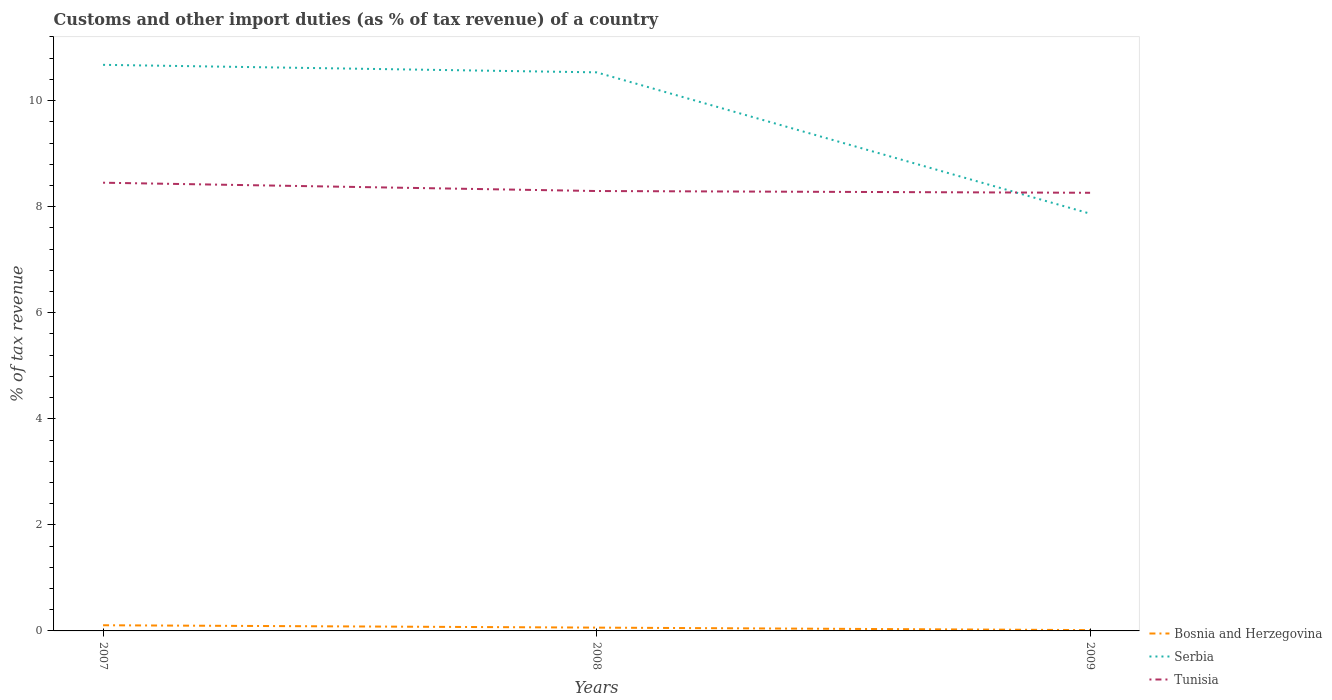How many different coloured lines are there?
Offer a terse response. 3. Does the line corresponding to Tunisia intersect with the line corresponding to Serbia?
Offer a terse response. Yes. Across all years, what is the maximum percentage of tax revenue from customs in Bosnia and Herzegovina?
Keep it short and to the point. 0.02. In which year was the percentage of tax revenue from customs in Tunisia maximum?
Your response must be concise. 2009. What is the total percentage of tax revenue from customs in Serbia in the graph?
Give a very brief answer. 2.81. What is the difference between the highest and the second highest percentage of tax revenue from customs in Tunisia?
Ensure brevity in your answer.  0.19. What is the difference between the highest and the lowest percentage of tax revenue from customs in Bosnia and Herzegovina?
Offer a terse response. 2. How many years are there in the graph?
Keep it short and to the point. 3. Does the graph contain any zero values?
Give a very brief answer. No. Where does the legend appear in the graph?
Make the answer very short. Bottom right. What is the title of the graph?
Offer a terse response. Customs and other import duties (as % of tax revenue) of a country. What is the label or title of the Y-axis?
Make the answer very short. % of tax revenue. What is the % of tax revenue of Bosnia and Herzegovina in 2007?
Your answer should be compact. 0.11. What is the % of tax revenue of Serbia in 2007?
Keep it short and to the point. 10.67. What is the % of tax revenue in Tunisia in 2007?
Provide a succinct answer. 8.45. What is the % of tax revenue of Bosnia and Herzegovina in 2008?
Keep it short and to the point. 0.06. What is the % of tax revenue in Serbia in 2008?
Offer a very short reply. 10.53. What is the % of tax revenue in Tunisia in 2008?
Give a very brief answer. 8.3. What is the % of tax revenue of Bosnia and Herzegovina in 2009?
Offer a terse response. 0.02. What is the % of tax revenue of Serbia in 2009?
Your answer should be compact. 7.87. What is the % of tax revenue of Tunisia in 2009?
Ensure brevity in your answer.  8.26. Across all years, what is the maximum % of tax revenue of Bosnia and Herzegovina?
Keep it short and to the point. 0.11. Across all years, what is the maximum % of tax revenue in Serbia?
Your answer should be very brief. 10.67. Across all years, what is the maximum % of tax revenue in Tunisia?
Offer a very short reply. 8.45. Across all years, what is the minimum % of tax revenue of Bosnia and Herzegovina?
Your answer should be compact. 0.02. Across all years, what is the minimum % of tax revenue of Serbia?
Keep it short and to the point. 7.87. Across all years, what is the minimum % of tax revenue of Tunisia?
Make the answer very short. 8.26. What is the total % of tax revenue in Bosnia and Herzegovina in the graph?
Give a very brief answer. 0.18. What is the total % of tax revenue of Serbia in the graph?
Offer a terse response. 29.08. What is the total % of tax revenue of Tunisia in the graph?
Ensure brevity in your answer.  25.01. What is the difference between the % of tax revenue in Bosnia and Herzegovina in 2007 and that in 2008?
Ensure brevity in your answer.  0.04. What is the difference between the % of tax revenue of Serbia in 2007 and that in 2008?
Ensure brevity in your answer.  0.14. What is the difference between the % of tax revenue in Tunisia in 2007 and that in 2008?
Make the answer very short. 0.16. What is the difference between the % of tax revenue of Bosnia and Herzegovina in 2007 and that in 2009?
Provide a succinct answer. 0.09. What is the difference between the % of tax revenue in Serbia in 2007 and that in 2009?
Keep it short and to the point. 2.81. What is the difference between the % of tax revenue of Tunisia in 2007 and that in 2009?
Your response must be concise. 0.19. What is the difference between the % of tax revenue of Bosnia and Herzegovina in 2008 and that in 2009?
Your answer should be compact. 0.05. What is the difference between the % of tax revenue in Serbia in 2008 and that in 2009?
Provide a succinct answer. 2.66. What is the difference between the % of tax revenue of Tunisia in 2008 and that in 2009?
Make the answer very short. 0.03. What is the difference between the % of tax revenue of Bosnia and Herzegovina in 2007 and the % of tax revenue of Serbia in 2008?
Offer a terse response. -10.43. What is the difference between the % of tax revenue in Bosnia and Herzegovina in 2007 and the % of tax revenue in Tunisia in 2008?
Offer a terse response. -8.19. What is the difference between the % of tax revenue in Serbia in 2007 and the % of tax revenue in Tunisia in 2008?
Make the answer very short. 2.38. What is the difference between the % of tax revenue of Bosnia and Herzegovina in 2007 and the % of tax revenue of Serbia in 2009?
Your answer should be compact. -7.76. What is the difference between the % of tax revenue in Bosnia and Herzegovina in 2007 and the % of tax revenue in Tunisia in 2009?
Ensure brevity in your answer.  -8.15. What is the difference between the % of tax revenue of Serbia in 2007 and the % of tax revenue of Tunisia in 2009?
Offer a very short reply. 2.41. What is the difference between the % of tax revenue in Bosnia and Herzegovina in 2008 and the % of tax revenue in Serbia in 2009?
Your answer should be compact. -7.81. What is the difference between the % of tax revenue in Bosnia and Herzegovina in 2008 and the % of tax revenue in Tunisia in 2009?
Provide a short and direct response. -8.2. What is the difference between the % of tax revenue in Serbia in 2008 and the % of tax revenue in Tunisia in 2009?
Give a very brief answer. 2.27. What is the average % of tax revenue in Bosnia and Herzegovina per year?
Provide a succinct answer. 0.06. What is the average % of tax revenue of Serbia per year?
Your answer should be compact. 9.69. What is the average % of tax revenue in Tunisia per year?
Give a very brief answer. 8.34. In the year 2007, what is the difference between the % of tax revenue in Bosnia and Herzegovina and % of tax revenue in Serbia?
Offer a very short reply. -10.57. In the year 2007, what is the difference between the % of tax revenue of Bosnia and Herzegovina and % of tax revenue of Tunisia?
Keep it short and to the point. -8.34. In the year 2007, what is the difference between the % of tax revenue of Serbia and % of tax revenue of Tunisia?
Your answer should be very brief. 2.22. In the year 2008, what is the difference between the % of tax revenue of Bosnia and Herzegovina and % of tax revenue of Serbia?
Give a very brief answer. -10.47. In the year 2008, what is the difference between the % of tax revenue in Bosnia and Herzegovina and % of tax revenue in Tunisia?
Offer a terse response. -8.23. In the year 2008, what is the difference between the % of tax revenue of Serbia and % of tax revenue of Tunisia?
Your answer should be compact. 2.24. In the year 2009, what is the difference between the % of tax revenue of Bosnia and Herzegovina and % of tax revenue of Serbia?
Provide a short and direct response. -7.85. In the year 2009, what is the difference between the % of tax revenue in Bosnia and Herzegovina and % of tax revenue in Tunisia?
Provide a short and direct response. -8.25. In the year 2009, what is the difference between the % of tax revenue of Serbia and % of tax revenue of Tunisia?
Your response must be concise. -0.39. What is the ratio of the % of tax revenue of Bosnia and Herzegovina in 2007 to that in 2008?
Your response must be concise. 1.71. What is the ratio of the % of tax revenue of Serbia in 2007 to that in 2008?
Your answer should be very brief. 1.01. What is the ratio of the % of tax revenue in Tunisia in 2007 to that in 2008?
Keep it short and to the point. 1.02. What is the ratio of the % of tax revenue of Bosnia and Herzegovina in 2007 to that in 2009?
Ensure brevity in your answer.  6.91. What is the ratio of the % of tax revenue of Serbia in 2007 to that in 2009?
Ensure brevity in your answer.  1.36. What is the ratio of the % of tax revenue of Tunisia in 2007 to that in 2009?
Make the answer very short. 1.02. What is the ratio of the % of tax revenue in Bosnia and Herzegovina in 2008 to that in 2009?
Ensure brevity in your answer.  4.04. What is the ratio of the % of tax revenue in Serbia in 2008 to that in 2009?
Ensure brevity in your answer.  1.34. What is the ratio of the % of tax revenue of Tunisia in 2008 to that in 2009?
Offer a terse response. 1. What is the difference between the highest and the second highest % of tax revenue of Bosnia and Herzegovina?
Provide a short and direct response. 0.04. What is the difference between the highest and the second highest % of tax revenue in Serbia?
Give a very brief answer. 0.14. What is the difference between the highest and the second highest % of tax revenue in Tunisia?
Your answer should be compact. 0.16. What is the difference between the highest and the lowest % of tax revenue of Bosnia and Herzegovina?
Offer a very short reply. 0.09. What is the difference between the highest and the lowest % of tax revenue in Serbia?
Provide a short and direct response. 2.81. What is the difference between the highest and the lowest % of tax revenue in Tunisia?
Provide a succinct answer. 0.19. 